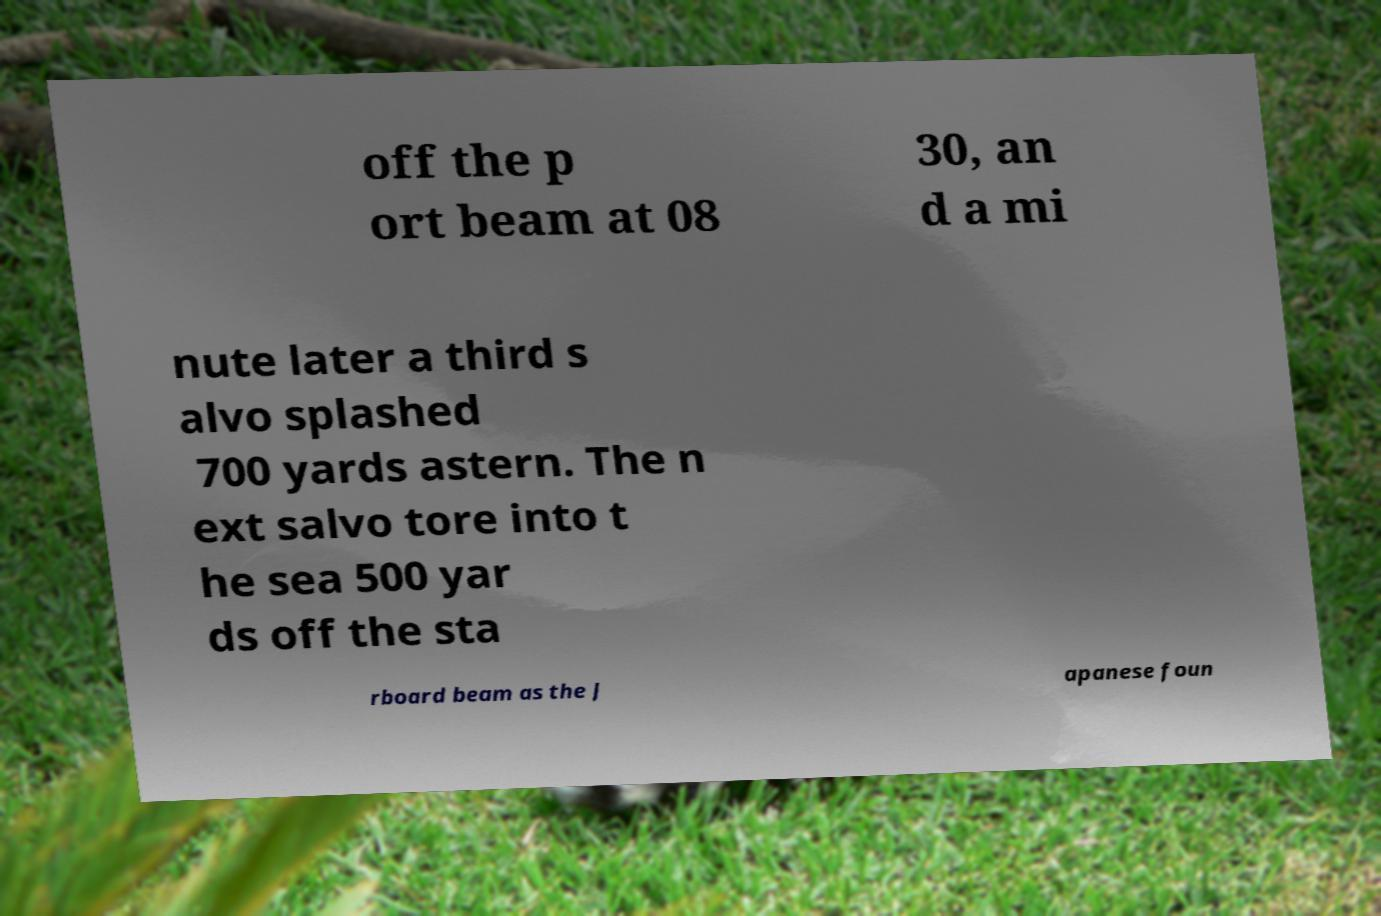Could you assist in decoding the text presented in this image and type it out clearly? off the p ort beam at 08 30, an d a mi nute later a third s alvo splashed 700 yards astern. The n ext salvo tore into t he sea 500 yar ds off the sta rboard beam as the J apanese foun 